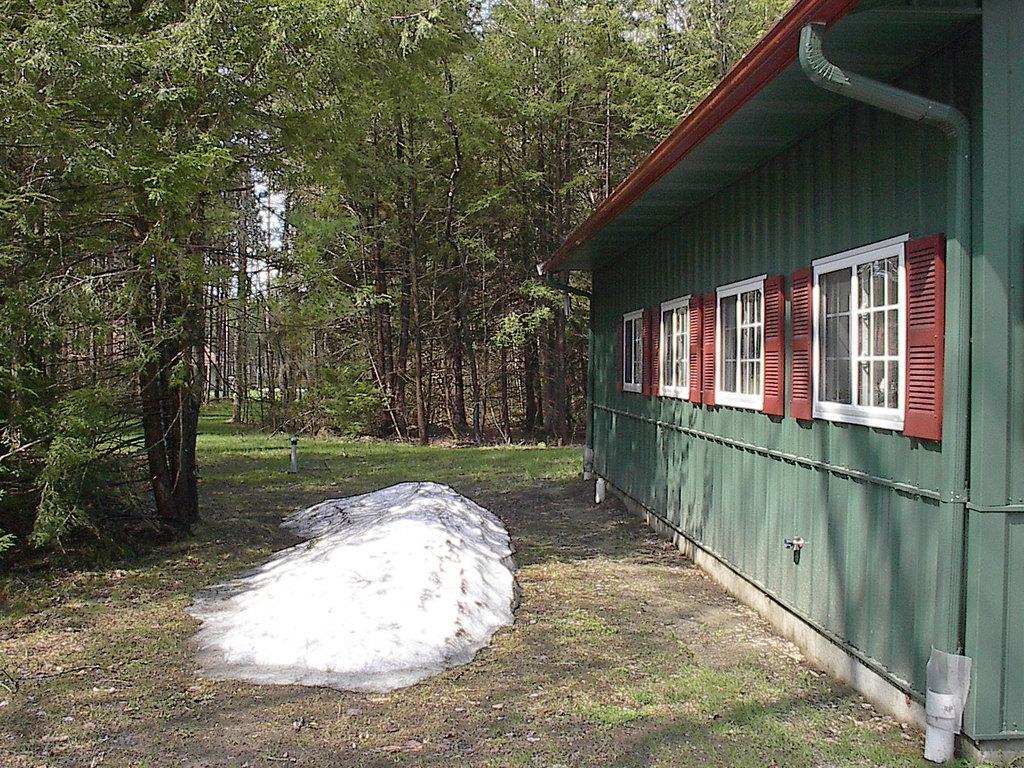In one or two sentences, can you explain what this image depicts? In this picture I can see a house with windows, and there are trees. 